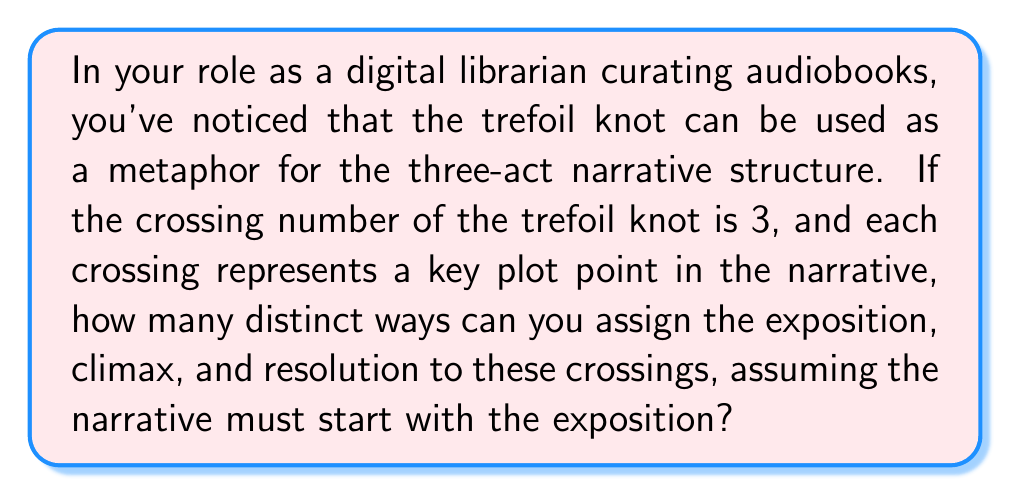Give your solution to this math problem. Let's approach this step-by-step:

1) The trefoil knot has a crossing number of 3, which means it has three distinct crossings.

2) In the three-act narrative structure, we have three key elements:
   - Exposition (E)
   - Climax (C)
   - Resolution (R)

3) We need to assign these three elements to the three crossings of the trefoil knot.

4) The question stipulates that the narrative must start with the exposition (E). This means E must be assigned to one of the crossings, and we need to determine how many ways we can arrange C and R in the remaining two crossings.

5) This is a permutation problem. We have 2 elements (C and R) to arrange in 2 positions.

6) The number of permutations is given by the formula:

   $$P(n,r) = n!$$

   Where $n$ is the number of elements to arrange, and $r$ is the number of positions (in this case, $n = r = 2$).

7) So, we have:

   $$P(2,2) = 2! = 2 \times 1 = 2$$

8) Therefore, there are 2 distinct ways to assign the climax and resolution after fixing the exposition at the start.

The two possible arrangements are:
1. E - C - R
2. E - R - C
Answer: 2 